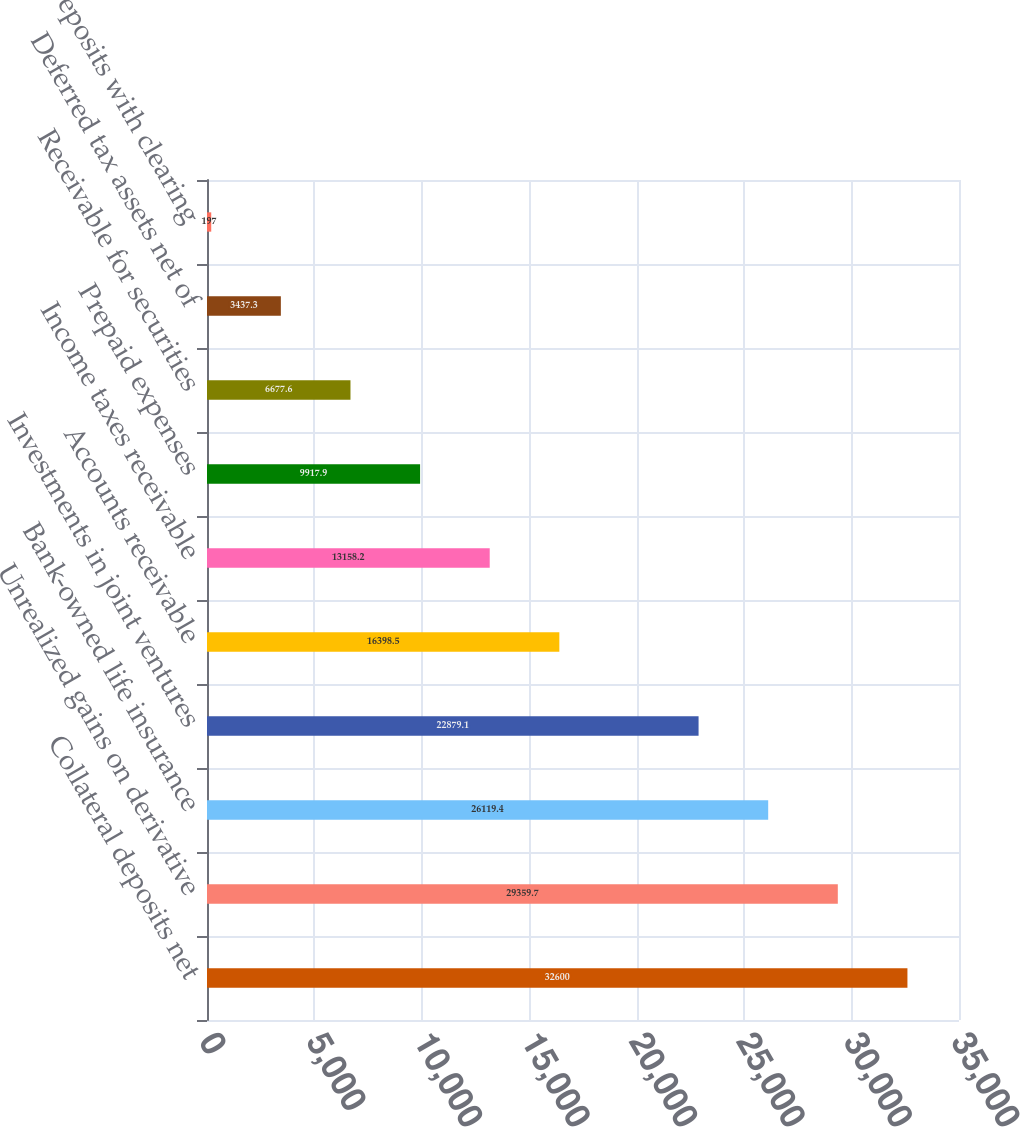<chart> <loc_0><loc_0><loc_500><loc_500><bar_chart><fcel>Collateral deposits net<fcel>Unrealized gains on derivative<fcel>Bank-owned life insurance<fcel>Investments in joint ventures<fcel>Accounts receivable<fcel>Income taxes receivable<fcel>Prepaid expenses<fcel>Receivable for securities<fcel>Deferred tax assets net of<fcel>Deposits with clearing<nl><fcel>32600<fcel>29359.7<fcel>26119.4<fcel>22879.1<fcel>16398.5<fcel>13158.2<fcel>9917.9<fcel>6677.6<fcel>3437.3<fcel>197<nl></chart> 